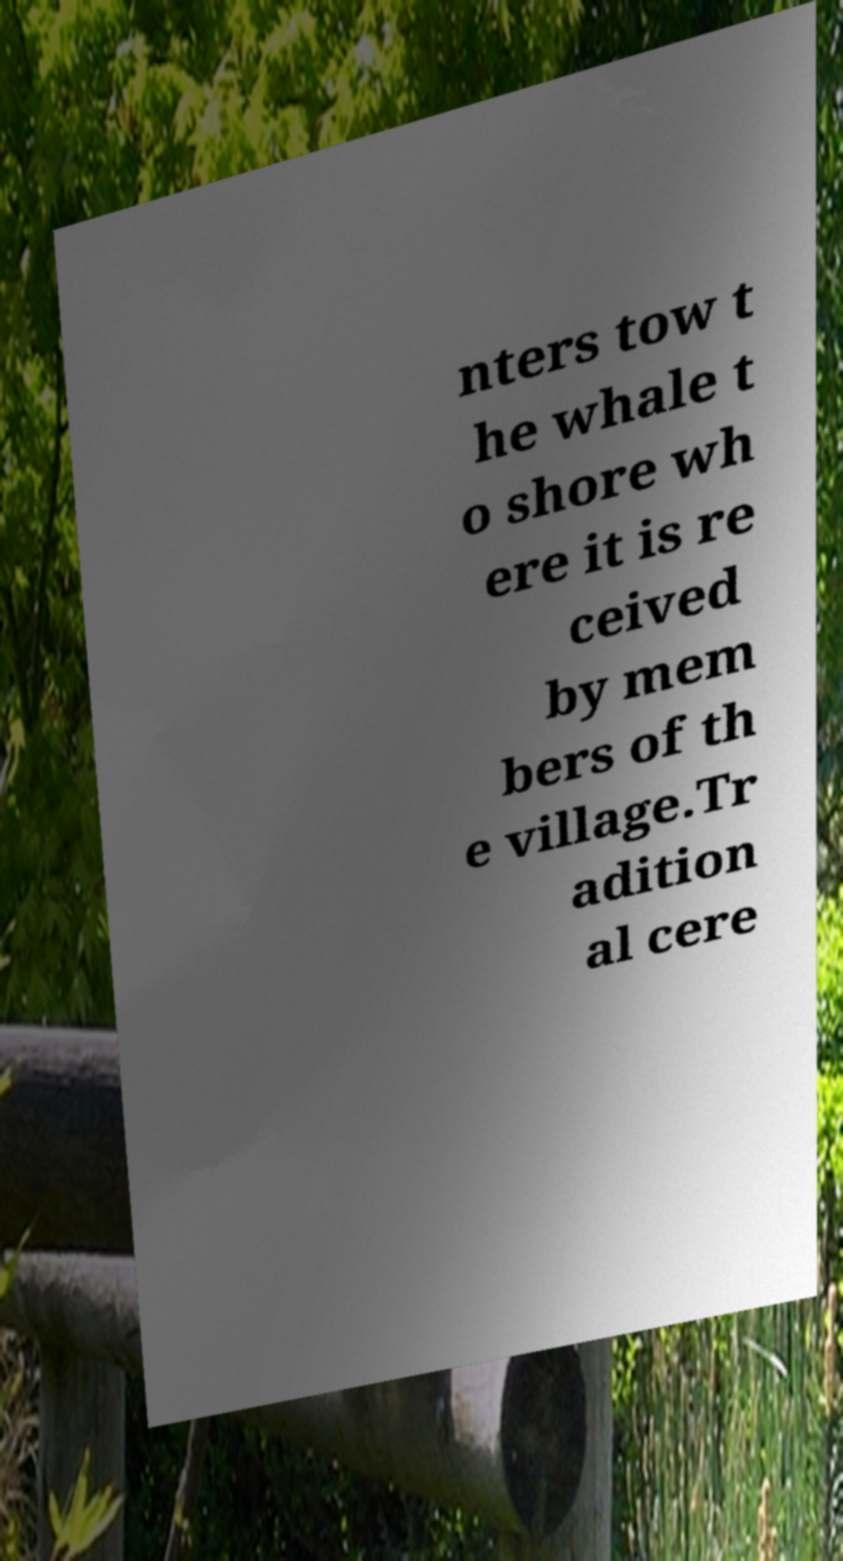Can you accurately transcribe the text from the provided image for me? nters tow t he whale t o shore wh ere it is re ceived by mem bers of th e village.Tr adition al cere 